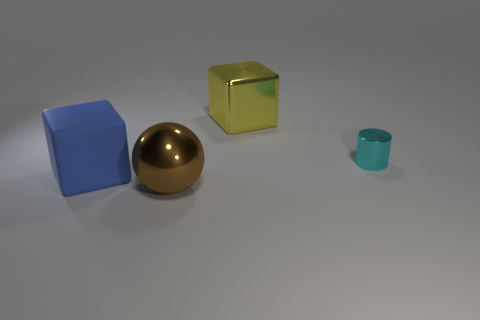Can you describe the lighting and atmosphere of the scene? The scene is softly lit, with what seems to be a single light source coming from above, casting gentle shadows beneath each object. The lighting creates a tranquil and somewhat sterile atmosphere, lacking any distinct mood or time of day. The plain background and the lack of any additional context give the scene a neutral feeling, mainly focusing on the objects themselves. 